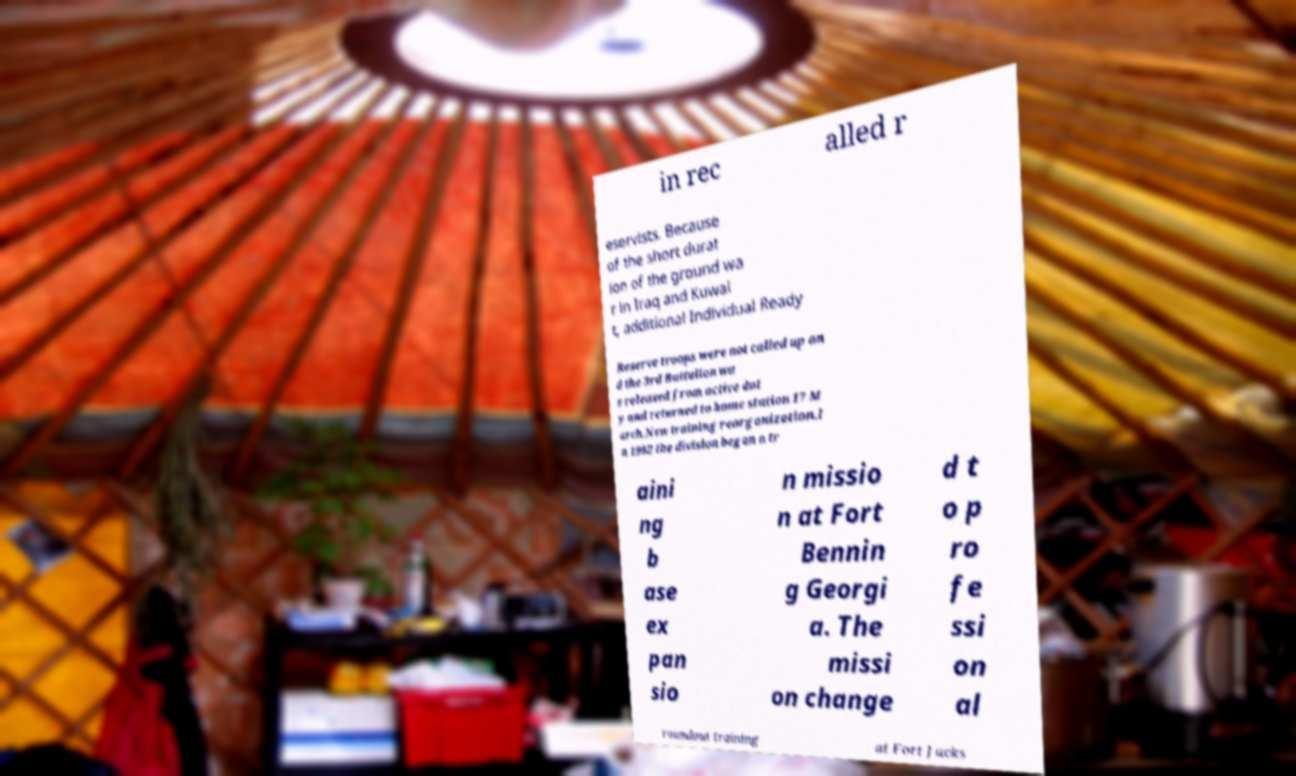Could you extract and type out the text from this image? in rec alled r eservists. Because of the short durat ion of the ground wa r in Iraq and Kuwai t, additional Individual Ready Reserve troops were not called up an d the 3rd Battalion wa s released from active dut y and returned to home station 17 M arch.New training reorganization.I n 1992 the division began a tr aini ng b ase ex pan sio n missio n at Fort Bennin g Georgi a. The missi on change d t o p ro fe ssi on al roundout training at Fort Jacks 